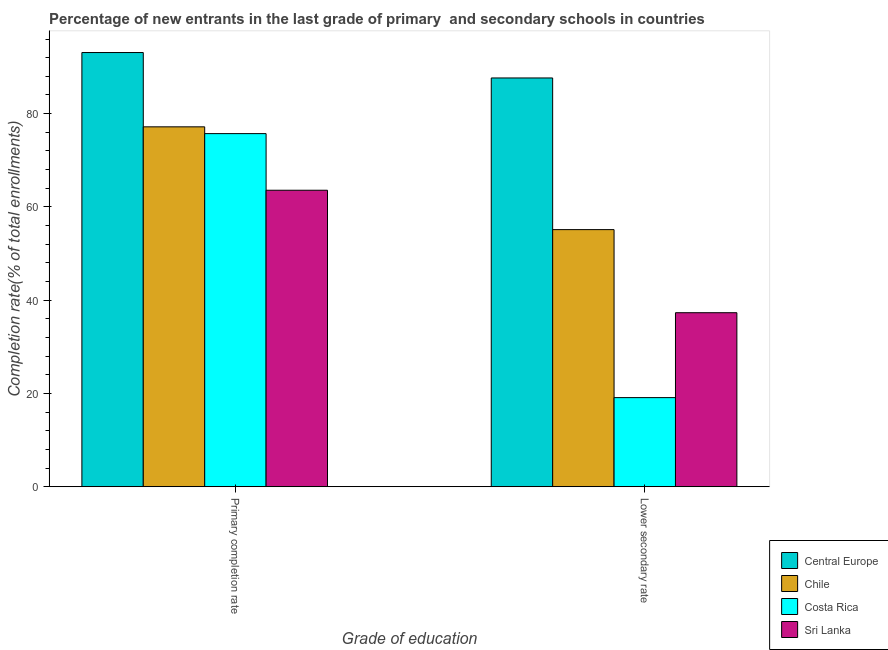How many different coloured bars are there?
Provide a succinct answer. 4. How many groups of bars are there?
Give a very brief answer. 2. Are the number of bars per tick equal to the number of legend labels?
Your answer should be very brief. Yes. What is the label of the 2nd group of bars from the left?
Provide a succinct answer. Lower secondary rate. What is the completion rate in secondary schools in Chile?
Your response must be concise. 55.13. Across all countries, what is the maximum completion rate in secondary schools?
Provide a short and direct response. 87.65. Across all countries, what is the minimum completion rate in secondary schools?
Your response must be concise. 19.11. In which country was the completion rate in primary schools maximum?
Give a very brief answer. Central Europe. In which country was the completion rate in secondary schools minimum?
Make the answer very short. Costa Rica. What is the total completion rate in primary schools in the graph?
Offer a terse response. 309.56. What is the difference between the completion rate in primary schools in Costa Rica and that in Chile?
Make the answer very short. -1.45. What is the difference between the completion rate in secondary schools in Central Europe and the completion rate in primary schools in Chile?
Your response must be concise. 10.48. What is the average completion rate in secondary schools per country?
Provide a succinct answer. 49.8. What is the difference between the completion rate in secondary schools and completion rate in primary schools in Costa Rica?
Ensure brevity in your answer.  -56.61. What is the ratio of the completion rate in primary schools in Chile to that in Costa Rica?
Give a very brief answer. 1.02. In how many countries, is the completion rate in primary schools greater than the average completion rate in primary schools taken over all countries?
Make the answer very short. 1. How many bars are there?
Make the answer very short. 8. Are all the bars in the graph horizontal?
Ensure brevity in your answer.  No. Are the values on the major ticks of Y-axis written in scientific E-notation?
Your response must be concise. No. What is the title of the graph?
Offer a very short reply. Percentage of new entrants in the last grade of primary  and secondary schools in countries. What is the label or title of the X-axis?
Offer a terse response. Grade of education. What is the label or title of the Y-axis?
Make the answer very short. Completion rate(% of total enrollments). What is the Completion rate(% of total enrollments) of Central Europe in Primary completion rate?
Your answer should be very brief. 93.1. What is the Completion rate(% of total enrollments) of Chile in Primary completion rate?
Give a very brief answer. 77.17. What is the Completion rate(% of total enrollments) in Costa Rica in Primary completion rate?
Offer a very short reply. 75.71. What is the Completion rate(% of total enrollments) of Sri Lanka in Primary completion rate?
Provide a succinct answer. 63.57. What is the Completion rate(% of total enrollments) of Central Europe in Lower secondary rate?
Provide a short and direct response. 87.65. What is the Completion rate(% of total enrollments) in Chile in Lower secondary rate?
Offer a very short reply. 55.13. What is the Completion rate(% of total enrollments) in Costa Rica in Lower secondary rate?
Your answer should be compact. 19.11. What is the Completion rate(% of total enrollments) of Sri Lanka in Lower secondary rate?
Offer a very short reply. 37.32. Across all Grade of education, what is the maximum Completion rate(% of total enrollments) in Central Europe?
Provide a succinct answer. 93.1. Across all Grade of education, what is the maximum Completion rate(% of total enrollments) in Chile?
Offer a very short reply. 77.17. Across all Grade of education, what is the maximum Completion rate(% of total enrollments) in Costa Rica?
Your answer should be compact. 75.71. Across all Grade of education, what is the maximum Completion rate(% of total enrollments) of Sri Lanka?
Make the answer very short. 63.57. Across all Grade of education, what is the minimum Completion rate(% of total enrollments) in Central Europe?
Keep it short and to the point. 87.65. Across all Grade of education, what is the minimum Completion rate(% of total enrollments) in Chile?
Offer a very short reply. 55.13. Across all Grade of education, what is the minimum Completion rate(% of total enrollments) in Costa Rica?
Your answer should be very brief. 19.11. Across all Grade of education, what is the minimum Completion rate(% of total enrollments) in Sri Lanka?
Provide a short and direct response. 37.32. What is the total Completion rate(% of total enrollments) of Central Europe in the graph?
Ensure brevity in your answer.  180.75. What is the total Completion rate(% of total enrollments) of Chile in the graph?
Your answer should be compact. 132.3. What is the total Completion rate(% of total enrollments) of Costa Rica in the graph?
Make the answer very short. 94.82. What is the total Completion rate(% of total enrollments) in Sri Lanka in the graph?
Your answer should be very brief. 100.89. What is the difference between the Completion rate(% of total enrollments) in Central Europe in Primary completion rate and that in Lower secondary rate?
Make the answer very short. 5.45. What is the difference between the Completion rate(% of total enrollments) of Chile in Primary completion rate and that in Lower secondary rate?
Ensure brevity in your answer.  22.04. What is the difference between the Completion rate(% of total enrollments) in Costa Rica in Primary completion rate and that in Lower secondary rate?
Offer a terse response. 56.61. What is the difference between the Completion rate(% of total enrollments) of Sri Lanka in Primary completion rate and that in Lower secondary rate?
Offer a very short reply. 26.26. What is the difference between the Completion rate(% of total enrollments) of Central Europe in Primary completion rate and the Completion rate(% of total enrollments) of Chile in Lower secondary rate?
Provide a succinct answer. 37.97. What is the difference between the Completion rate(% of total enrollments) of Central Europe in Primary completion rate and the Completion rate(% of total enrollments) of Costa Rica in Lower secondary rate?
Keep it short and to the point. 74. What is the difference between the Completion rate(% of total enrollments) in Central Europe in Primary completion rate and the Completion rate(% of total enrollments) in Sri Lanka in Lower secondary rate?
Provide a succinct answer. 55.79. What is the difference between the Completion rate(% of total enrollments) in Chile in Primary completion rate and the Completion rate(% of total enrollments) in Costa Rica in Lower secondary rate?
Your response must be concise. 58.06. What is the difference between the Completion rate(% of total enrollments) in Chile in Primary completion rate and the Completion rate(% of total enrollments) in Sri Lanka in Lower secondary rate?
Your answer should be very brief. 39.85. What is the difference between the Completion rate(% of total enrollments) in Costa Rica in Primary completion rate and the Completion rate(% of total enrollments) in Sri Lanka in Lower secondary rate?
Your answer should be compact. 38.4. What is the average Completion rate(% of total enrollments) in Central Europe per Grade of education?
Make the answer very short. 90.38. What is the average Completion rate(% of total enrollments) of Chile per Grade of education?
Ensure brevity in your answer.  66.15. What is the average Completion rate(% of total enrollments) of Costa Rica per Grade of education?
Offer a very short reply. 47.41. What is the average Completion rate(% of total enrollments) of Sri Lanka per Grade of education?
Your answer should be very brief. 50.44. What is the difference between the Completion rate(% of total enrollments) in Central Europe and Completion rate(% of total enrollments) in Chile in Primary completion rate?
Your response must be concise. 15.93. What is the difference between the Completion rate(% of total enrollments) in Central Europe and Completion rate(% of total enrollments) in Costa Rica in Primary completion rate?
Offer a very short reply. 17.39. What is the difference between the Completion rate(% of total enrollments) in Central Europe and Completion rate(% of total enrollments) in Sri Lanka in Primary completion rate?
Make the answer very short. 29.53. What is the difference between the Completion rate(% of total enrollments) of Chile and Completion rate(% of total enrollments) of Costa Rica in Primary completion rate?
Provide a succinct answer. 1.45. What is the difference between the Completion rate(% of total enrollments) of Chile and Completion rate(% of total enrollments) of Sri Lanka in Primary completion rate?
Your response must be concise. 13.6. What is the difference between the Completion rate(% of total enrollments) in Costa Rica and Completion rate(% of total enrollments) in Sri Lanka in Primary completion rate?
Give a very brief answer. 12.14. What is the difference between the Completion rate(% of total enrollments) in Central Europe and Completion rate(% of total enrollments) in Chile in Lower secondary rate?
Offer a very short reply. 32.52. What is the difference between the Completion rate(% of total enrollments) in Central Europe and Completion rate(% of total enrollments) in Costa Rica in Lower secondary rate?
Your response must be concise. 68.54. What is the difference between the Completion rate(% of total enrollments) in Central Europe and Completion rate(% of total enrollments) in Sri Lanka in Lower secondary rate?
Ensure brevity in your answer.  50.34. What is the difference between the Completion rate(% of total enrollments) of Chile and Completion rate(% of total enrollments) of Costa Rica in Lower secondary rate?
Offer a very short reply. 36.02. What is the difference between the Completion rate(% of total enrollments) in Chile and Completion rate(% of total enrollments) in Sri Lanka in Lower secondary rate?
Give a very brief answer. 17.82. What is the difference between the Completion rate(% of total enrollments) of Costa Rica and Completion rate(% of total enrollments) of Sri Lanka in Lower secondary rate?
Keep it short and to the point. -18.21. What is the ratio of the Completion rate(% of total enrollments) in Central Europe in Primary completion rate to that in Lower secondary rate?
Ensure brevity in your answer.  1.06. What is the ratio of the Completion rate(% of total enrollments) in Chile in Primary completion rate to that in Lower secondary rate?
Give a very brief answer. 1.4. What is the ratio of the Completion rate(% of total enrollments) in Costa Rica in Primary completion rate to that in Lower secondary rate?
Keep it short and to the point. 3.96. What is the ratio of the Completion rate(% of total enrollments) in Sri Lanka in Primary completion rate to that in Lower secondary rate?
Provide a short and direct response. 1.7. What is the difference between the highest and the second highest Completion rate(% of total enrollments) in Central Europe?
Keep it short and to the point. 5.45. What is the difference between the highest and the second highest Completion rate(% of total enrollments) in Chile?
Make the answer very short. 22.04. What is the difference between the highest and the second highest Completion rate(% of total enrollments) in Costa Rica?
Provide a succinct answer. 56.61. What is the difference between the highest and the second highest Completion rate(% of total enrollments) in Sri Lanka?
Provide a succinct answer. 26.26. What is the difference between the highest and the lowest Completion rate(% of total enrollments) in Central Europe?
Give a very brief answer. 5.45. What is the difference between the highest and the lowest Completion rate(% of total enrollments) of Chile?
Your answer should be compact. 22.04. What is the difference between the highest and the lowest Completion rate(% of total enrollments) of Costa Rica?
Make the answer very short. 56.61. What is the difference between the highest and the lowest Completion rate(% of total enrollments) of Sri Lanka?
Provide a succinct answer. 26.26. 